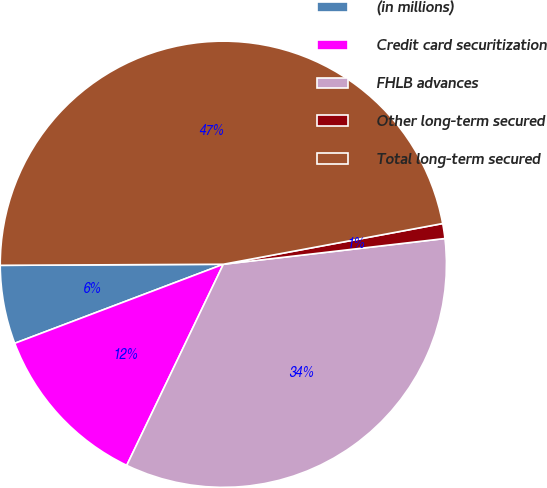Convert chart. <chart><loc_0><loc_0><loc_500><loc_500><pie_chart><fcel>(in millions)<fcel>Credit card securitization<fcel>FHLB advances<fcel>Other long-term secured<fcel>Total long-term secured<nl><fcel>5.69%<fcel>12.11%<fcel>33.97%<fcel>1.08%<fcel>47.16%<nl></chart> 